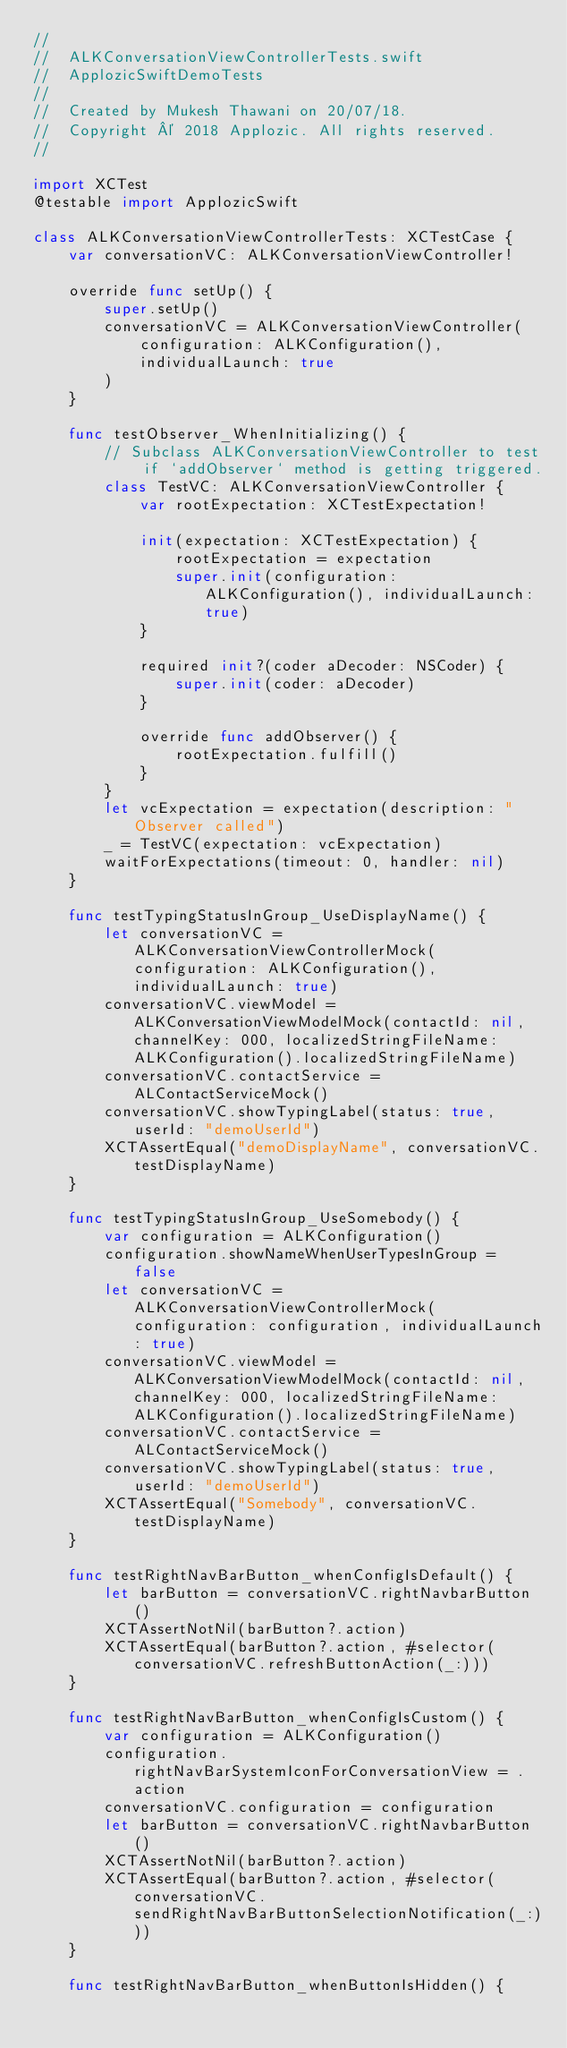Convert code to text. <code><loc_0><loc_0><loc_500><loc_500><_Swift_>//
//  ALKConversationViewControllerTests.swift
//  ApplozicSwiftDemoTests
//
//  Created by Mukesh Thawani on 20/07/18.
//  Copyright © 2018 Applozic. All rights reserved.
//

import XCTest
@testable import ApplozicSwift

class ALKConversationViewControllerTests: XCTestCase {
    var conversationVC: ALKConversationViewController!

    override func setUp() {
        super.setUp()
        conversationVC = ALKConversationViewController(
            configuration: ALKConfiguration(),
            individualLaunch: true
        )
    }

    func testObserver_WhenInitializing() {
        // Subclass ALKConversationViewController to test if `addObserver` method is getting triggered.
        class TestVC: ALKConversationViewController {
            var rootExpectation: XCTestExpectation!

            init(expectation: XCTestExpectation) {
                rootExpectation = expectation
                super.init(configuration: ALKConfiguration(), individualLaunch: true)
            }

            required init?(coder aDecoder: NSCoder) {
                super.init(coder: aDecoder)
            }

            override func addObserver() {
                rootExpectation.fulfill()
            }
        }
        let vcExpectation = expectation(description: "Observer called")
        _ = TestVC(expectation: vcExpectation)
        waitForExpectations(timeout: 0, handler: nil)
    }

    func testTypingStatusInGroup_UseDisplayName() {
        let conversationVC = ALKConversationViewControllerMock(configuration: ALKConfiguration(), individualLaunch: true)
        conversationVC.viewModel = ALKConversationViewModelMock(contactId: nil, channelKey: 000, localizedStringFileName: ALKConfiguration().localizedStringFileName)
        conversationVC.contactService = ALContactServiceMock()
        conversationVC.showTypingLabel(status: true, userId: "demoUserId")
        XCTAssertEqual("demoDisplayName", conversationVC.testDisplayName)
    }

    func testTypingStatusInGroup_UseSomebody() {
        var configuration = ALKConfiguration()
        configuration.showNameWhenUserTypesInGroup = false
        let conversationVC = ALKConversationViewControllerMock(configuration: configuration, individualLaunch: true)
        conversationVC.viewModel = ALKConversationViewModelMock(contactId: nil, channelKey: 000, localizedStringFileName: ALKConfiguration().localizedStringFileName)
        conversationVC.contactService = ALContactServiceMock()
        conversationVC.showTypingLabel(status: true, userId: "demoUserId")
        XCTAssertEqual("Somebody", conversationVC.testDisplayName)
    }

    func testRightNavBarButton_whenConfigIsDefault() {
        let barButton = conversationVC.rightNavbarButton()
        XCTAssertNotNil(barButton?.action)
        XCTAssertEqual(barButton?.action, #selector(conversationVC.refreshButtonAction(_:)))
    }

    func testRightNavBarButton_whenConfigIsCustom() {
        var configuration = ALKConfiguration()
        configuration.rightNavBarSystemIconForConversationView = .action
        conversationVC.configuration = configuration
        let barButton = conversationVC.rightNavbarButton()
        XCTAssertNotNil(barButton?.action)
        XCTAssertEqual(barButton?.action, #selector(conversationVC.sendRightNavBarButtonSelectionNotification(_:)))
    }

    func testRightNavBarButton_whenButtonIsHidden() {</code> 